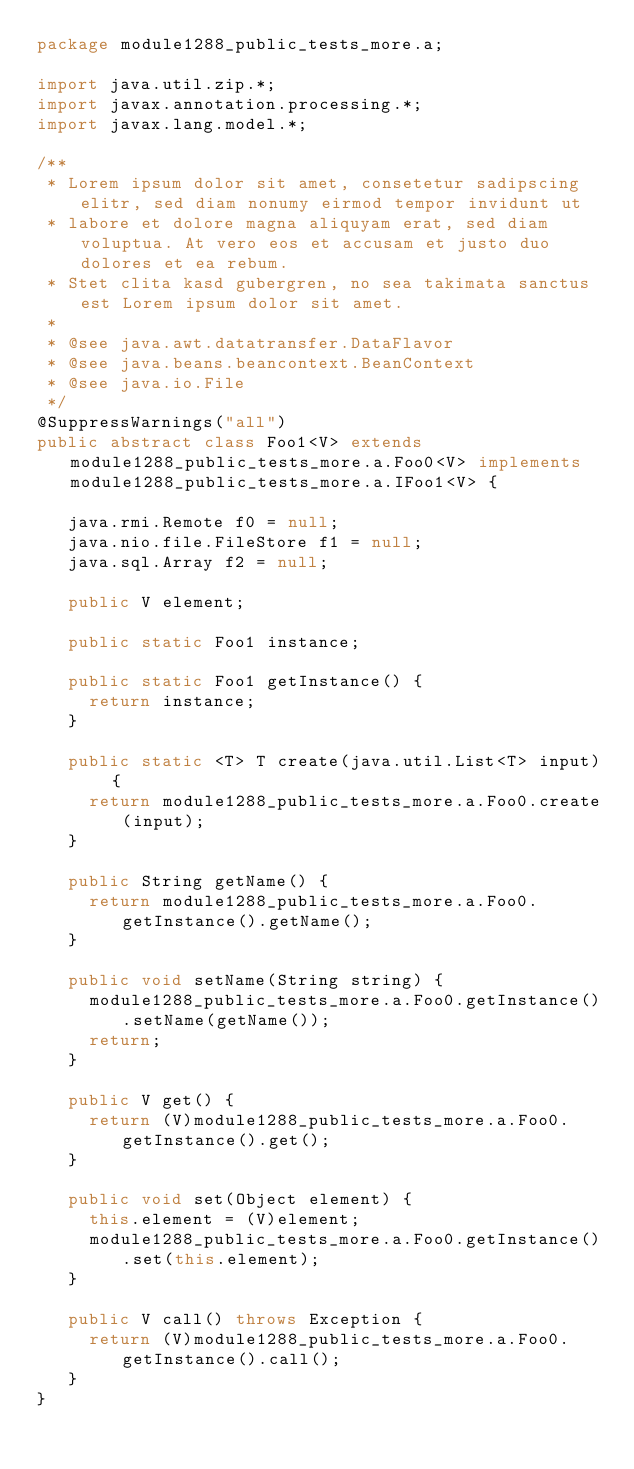Convert code to text. <code><loc_0><loc_0><loc_500><loc_500><_Java_>package module1288_public_tests_more.a;

import java.util.zip.*;
import javax.annotation.processing.*;
import javax.lang.model.*;

/**
 * Lorem ipsum dolor sit amet, consetetur sadipscing elitr, sed diam nonumy eirmod tempor invidunt ut 
 * labore et dolore magna aliquyam erat, sed diam voluptua. At vero eos et accusam et justo duo dolores et ea rebum. 
 * Stet clita kasd gubergren, no sea takimata sanctus est Lorem ipsum dolor sit amet. 
 *
 * @see java.awt.datatransfer.DataFlavor
 * @see java.beans.beancontext.BeanContext
 * @see java.io.File
 */
@SuppressWarnings("all")
public abstract class Foo1<V> extends module1288_public_tests_more.a.Foo0<V> implements module1288_public_tests_more.a.IFoo1<V> {

	 java.rmi.Remote f0 = null;
	 java.nio.file.FileStore f1 = null;
	 java.sql.Array f2 = null;

	 public V element;

	 public static Foo1 instance;

	 public static Foo1 getInstance() {
	 	 return instance;
	 }

	 public static <T> T create(java.util.List<T> input) {
	 	 return module1288_public_tests_more.a.Foo0.create(input);
	 }

	 public String getName() {
	 	 return module1288_public_tests_more.a.Foo0.getInstance().getName();
	 }

	 public void setName(String string) {
	 	 module1288_public_tests_more.a.Foo0.getInstance().setName(getName());
	 	 return;
	 }

	 public V get() {
	 	 return (V)module1288_public_tests_more.a.Foo0.getInstance().get();
	 }

	 public void set(Object element) {
	 	 this.element = (V)element;
	 	 module1288_public_tests_more.a.Foo0.getInstance().set(this.element);
	 }

	 public V call() throws Exception {
	 	 return (V)module1288_public_tests_more.a.Foo0.getInstance().call();
	 }
}
</code> 